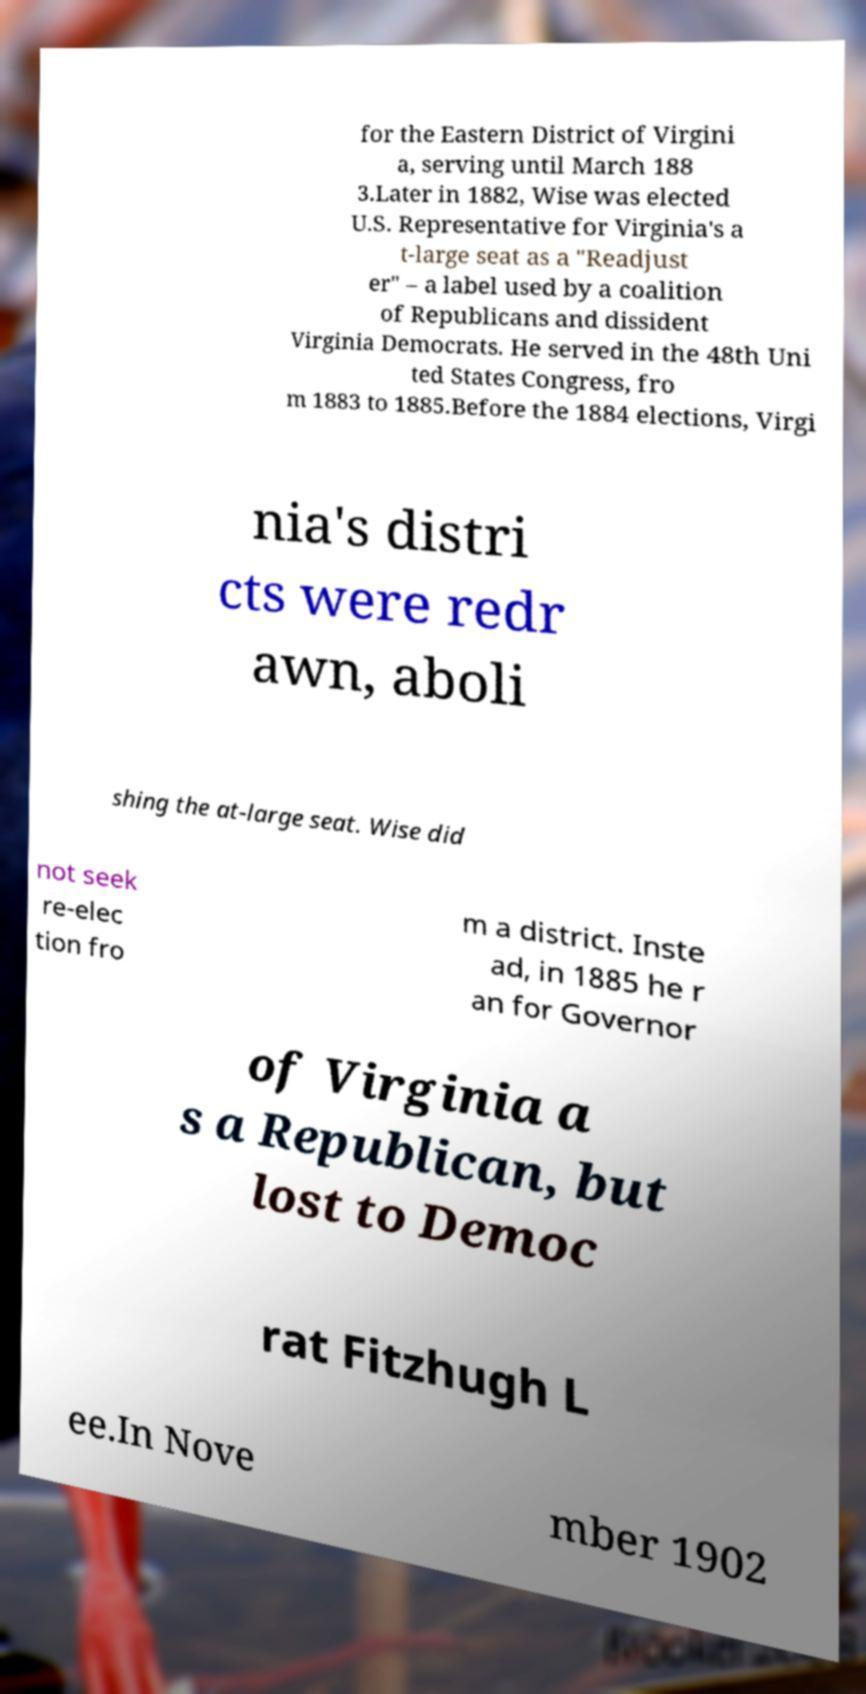For documentation purposes, I need the text within this image transcribed. Could you provide that? for the Eastern District of Virgini a, serving until March 188 3.Later in 1882, Wise was elected U.S. Representative for Virginia's a t-large seat as a "Readjust er" – a label used by a coalition of Republicans and dissident Virginia Democrats. He served in the 48th Uni ted States Congress, fro m 1883 to 1885.Before the 1884 elections, Virgi nia's distri cts were redr awn, aboli shing the at-large seat. Wise did not seek re-elec tion fro m a district. Inste ad, in 1885 he r an for Governor of Virginia a s a Republican, but lost to Democ rat Fitzhugh L ee.In Nove mber 1902 